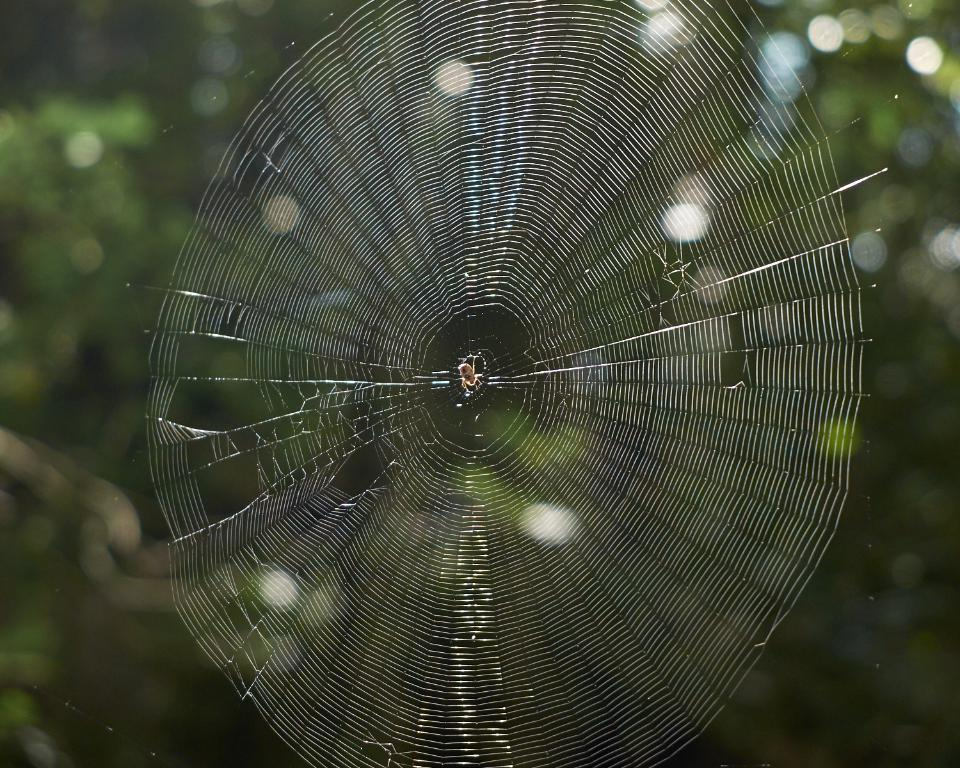What is the main subject of the image? There is a spider in the image. What is associated with the spider in the image? There is a spider web in the image. Can you describe the background of the image? The background of the image is blurred. What type of bushes can be seen growing near the pipe in the image? There is no mention of bushes or a pipe in the image; it features a spider and a spider web. 